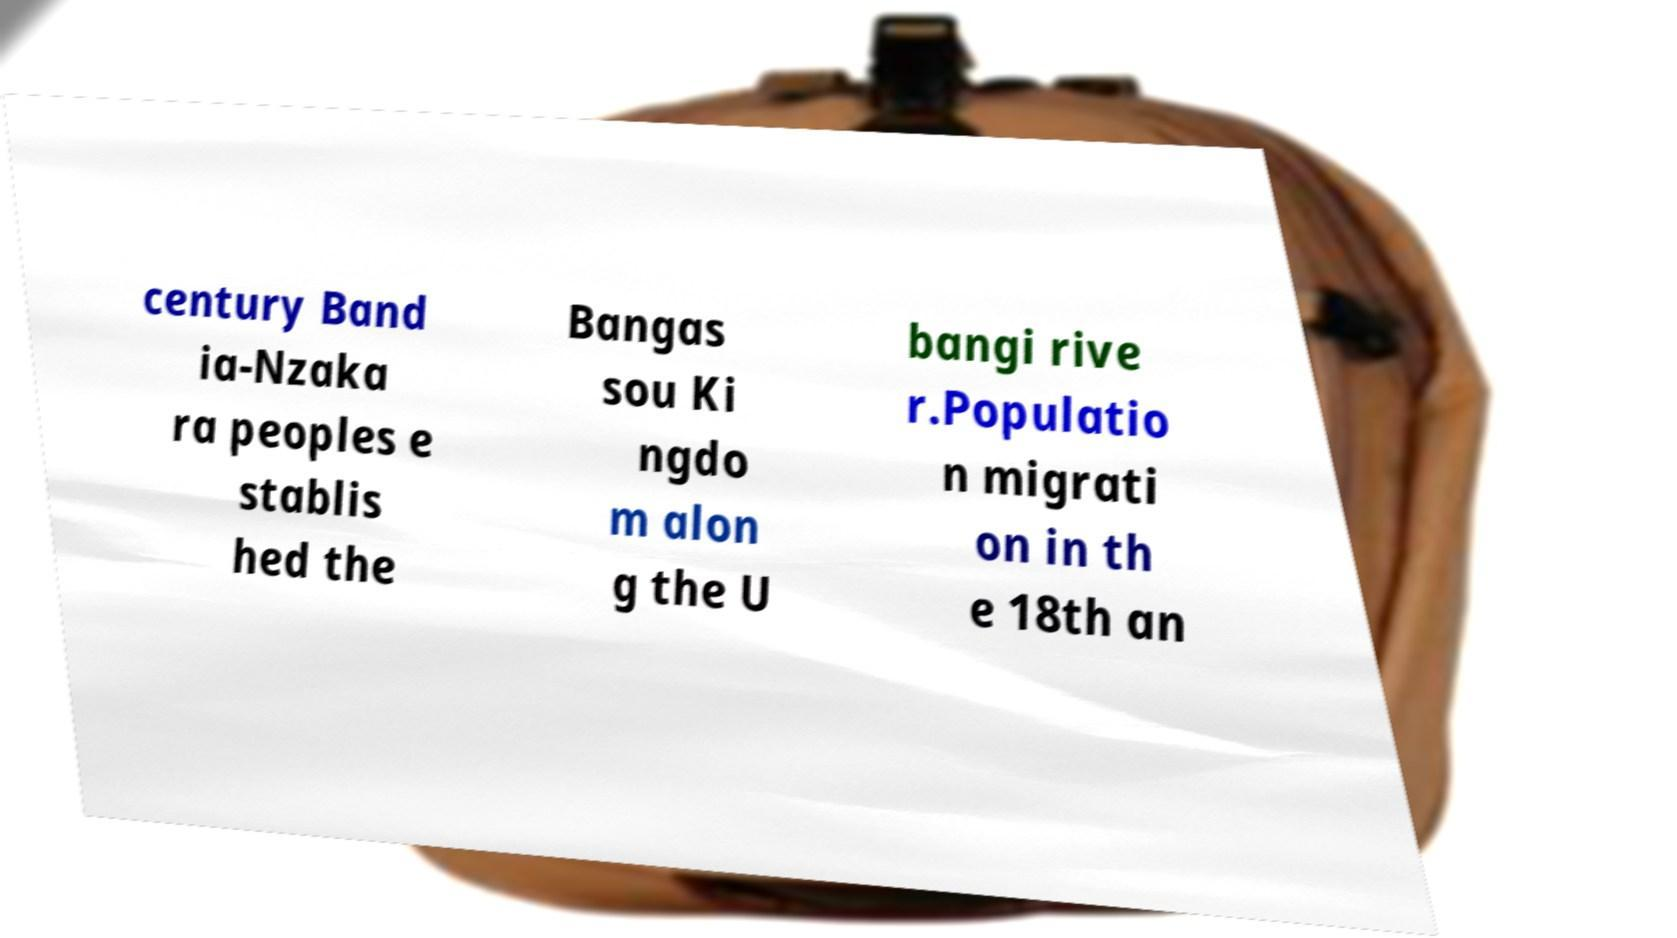I need the written content from this picture converted into text. Can you do that? century Band ia-Nzaka ra peoples e stablis hed the Bangas sou Ki ngdo m alon g the U bangi rive r.Populatio n migrati on in th e 18th an 